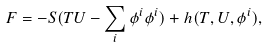Convert formula to latex. <formula><loc_0><loc_0><loc_500><loc_500>F = - S ( T U - \sum _ { i } \phi ^ { i } \phi ^ { i } ) + { h } ( T , U , \phi ^ { i } ) , \,</formula> 